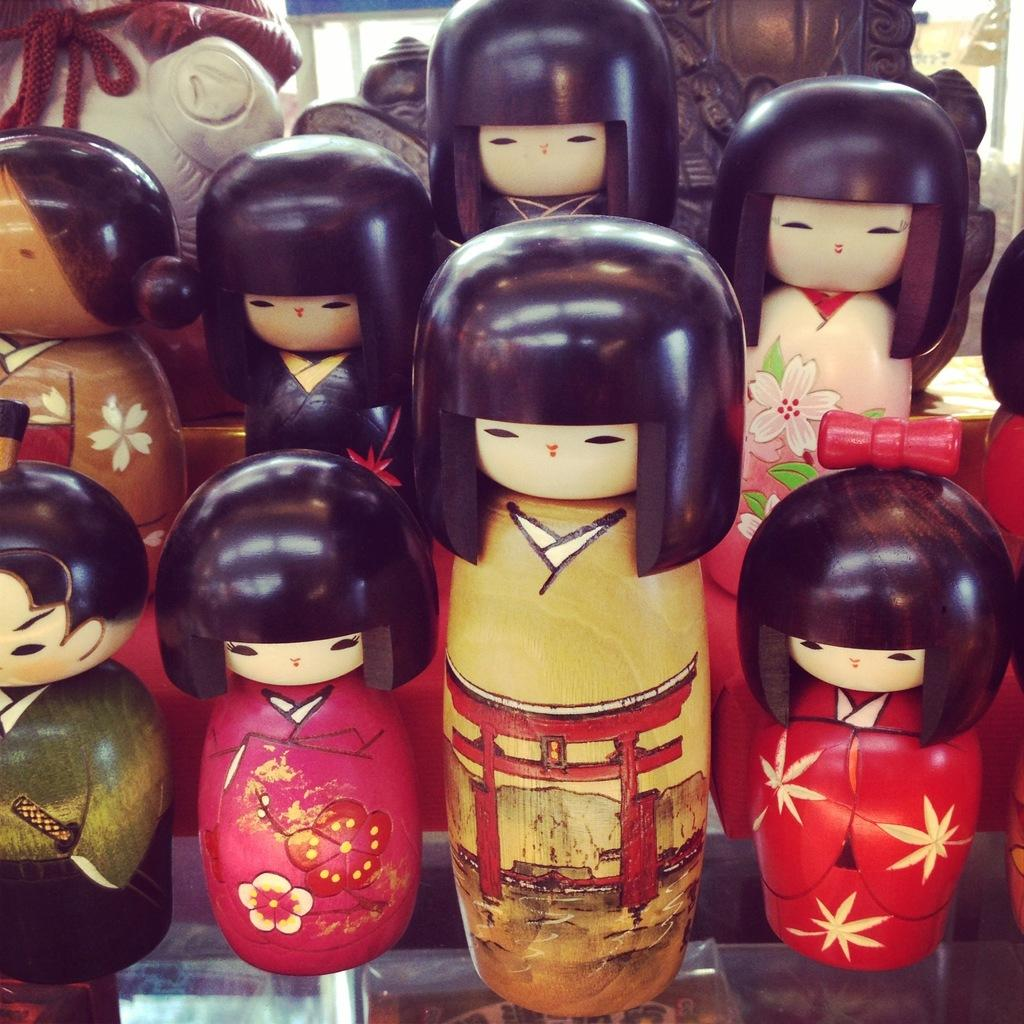What is the main subject of the image? The main subject of the image is a group of dolls. Where are the dolls located in the image? The dolls are on a surface in the image. What type of industry is depicted on the map in the image? There is no map present in the image, so it is not possible to answer that question. 